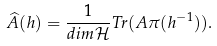Convert formula to latex. <formula><loc_0><loc_0><loc_500><loc_500>\widehat { A } ( h ) = \frac { 1 } { d i m \mathcal { H } } T r ( A \pi ( h ^ { - 1 } ) ) .</formula> 